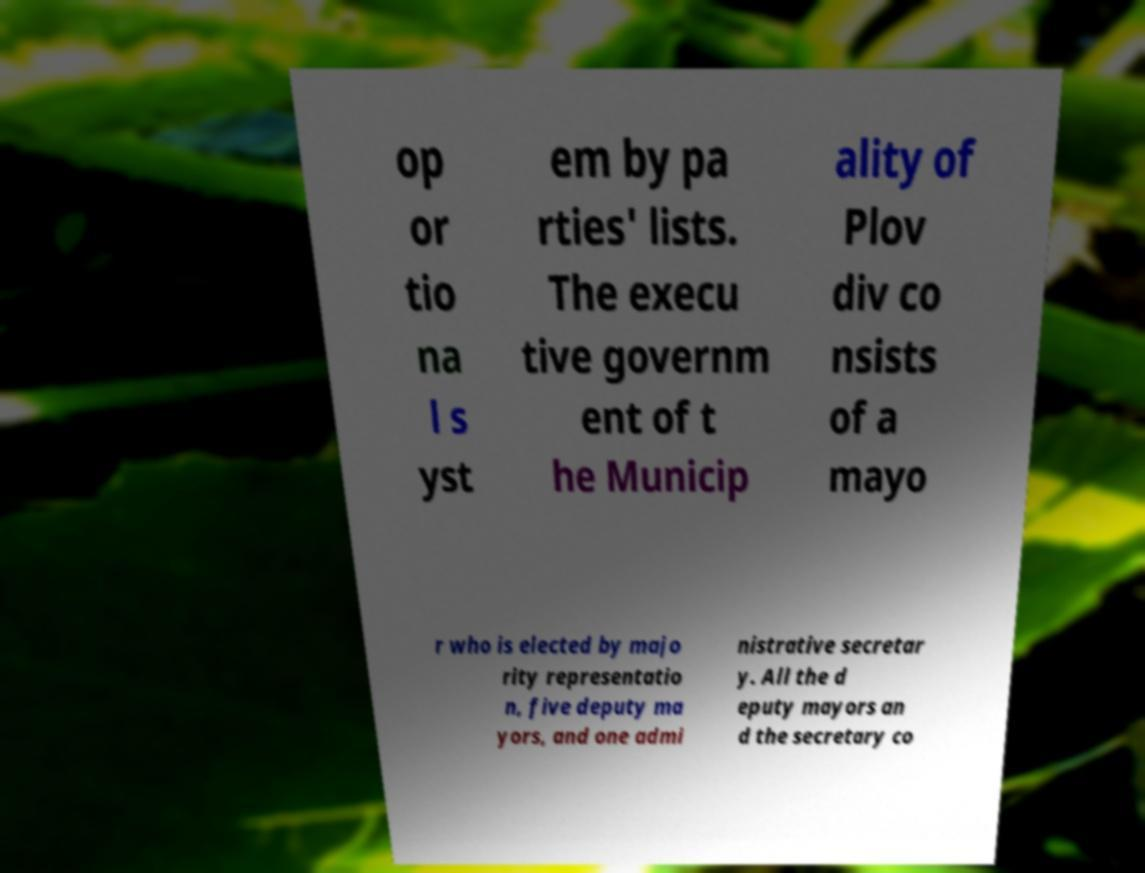What messages or text are displayed in this image? I need them in a readable, typed format. op or tio na l s yst em by pa rties' lists. The execu tive governm ent of t he Municip ality of Plov div co nsists of a mayo r who is elected by majo rity representatio n, five deputy ma yors, and one admi nistrative secretar y. All the d eputy mayors an d the secretary co 